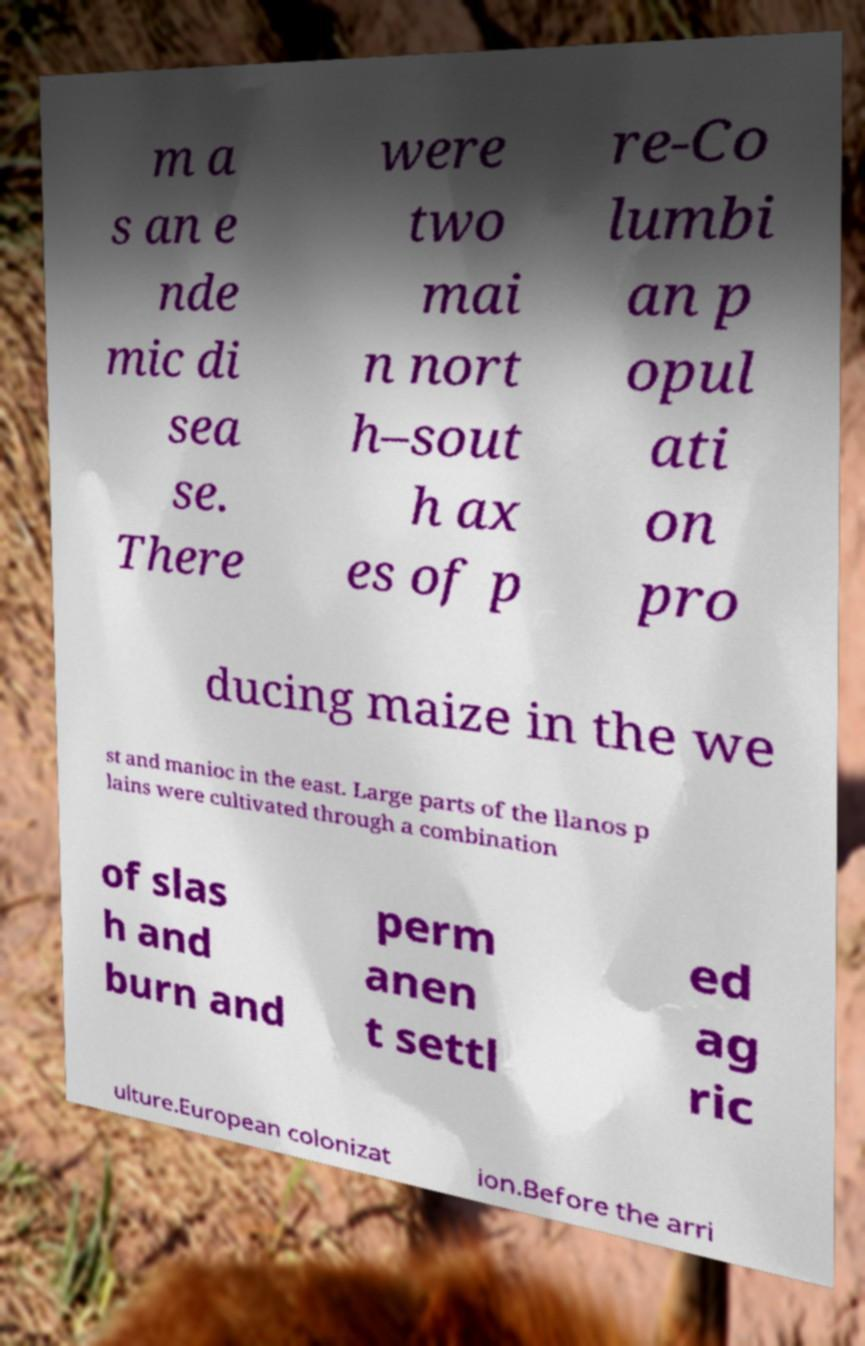Could you assist in decoding the text presented in this image and type it out clearly? m a s an e nde mic di sea se. There were two mai n nort h–sout h ax es of p re-Co lumbi an p opul ati on pro ducing maize in the we st and manioc in the east. Large parts of the llanos p lains were cultivated through a combination of slas h and burn and perm anen t settl ed ag ric ulture.European colonizat ion.Before the arri 